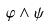<formula> <loc_0><loc_0><loc_500><loc_500>\varphi \wedge \psi</formula> 